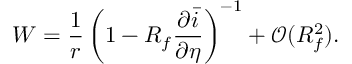<formula> <loc_0><loc_0><loc_500><loc_500>W = \frac { 1 } { r } \left ( 1 - R _ { f } \frac { \partial \bar { i } } { \partial \eta } \right ) ^ { - 1 } + \mathcal { O } ( R _ { f } ^ { 2 } ) .</formula> 